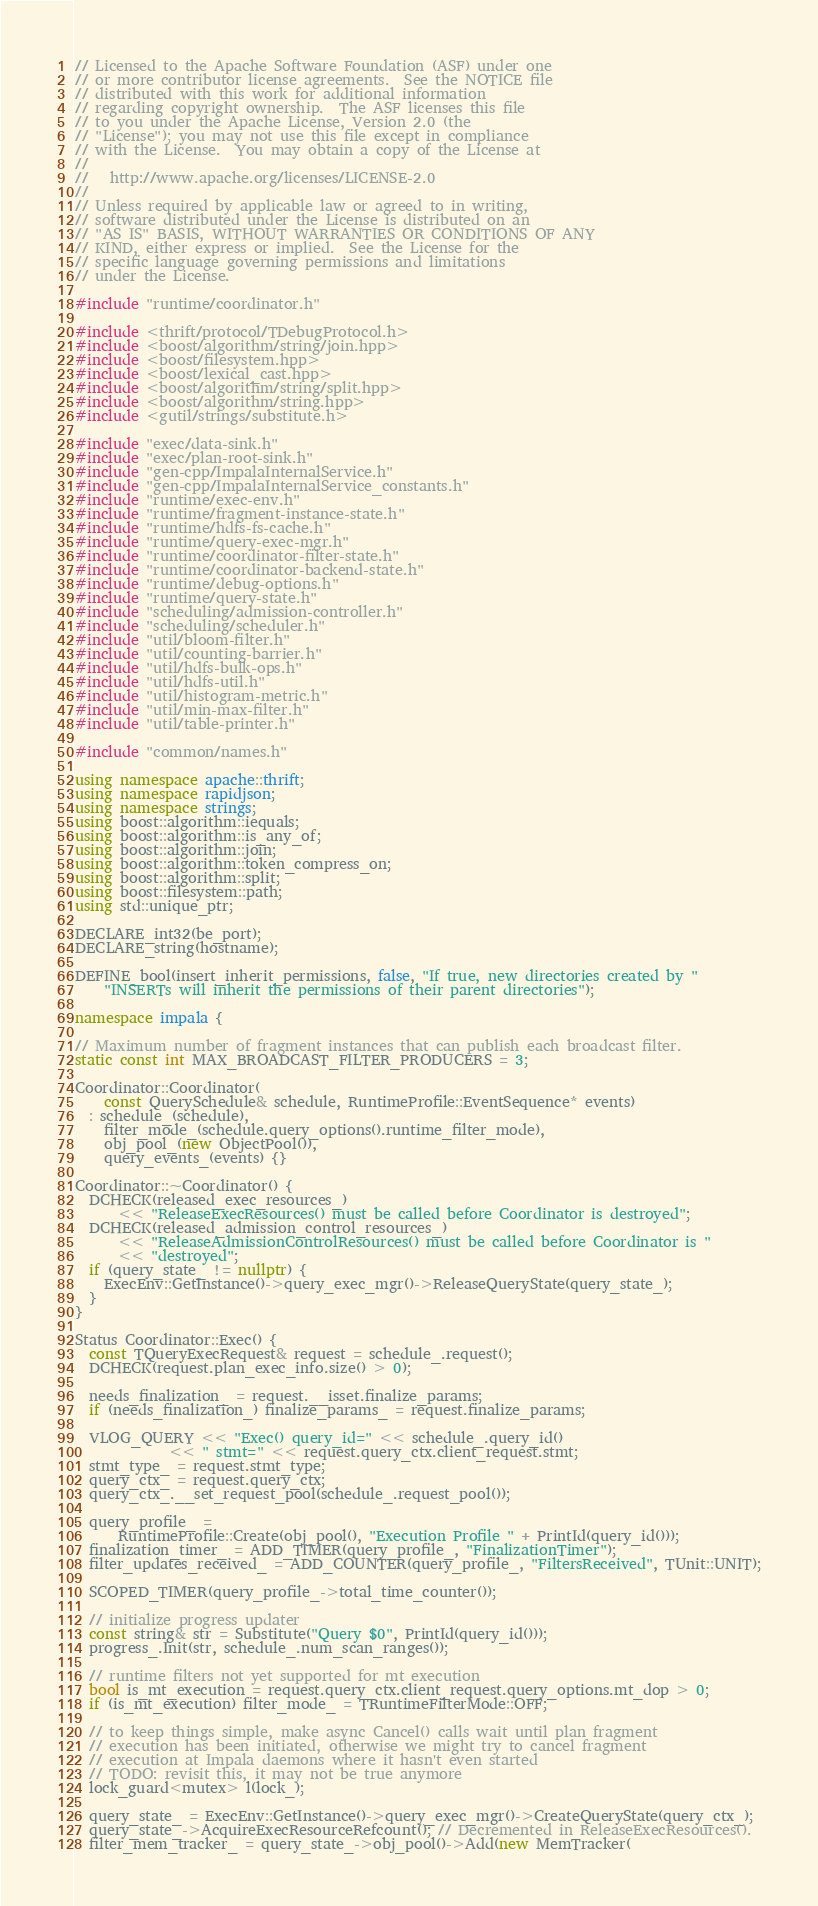<code> <loc_0><loc_0><loc_500><loc_500><_C++_>// Licensed to the Apache Software Foundation (ASF) under one
// or more contributor license agreements.  See the NOTICE file
// distributed with this work for additional information
// regarding copyright ownership.  The ASF licenses this file
// to you under the Apache License, Version 2.0 (the
// "License"); you may not use this file except in compliance
// with the License.  You may obtain a copy of the License at
//
//   http://www.apache.org/licenses/LICENSE-2.0
//
// Unless required by applicable law or agreed to in writing,
// software distributed under the License is distributed on an
// "AS IS" BASIS, WITHOUT WARRANTIES OR CONDITIONS OF ANY
// KIND, either express or implied.  See the License for the
// specific language governing permissions and limitations
// under the License.

#include "runtime/coordinator.h"

#include <thrift/protocol/TDebugProtocol.h>
#include <boost/algorithm/string/join.hpp>
#include <boost/filesystem.hpp>
#include <boost/lexical_cast.hpp>
#include <boost/algorithm/string/split.hpp>
#include <boost/algorithm/string.hpp>
#include <gutil/strings/substitute.h>

#include "exec/data-sink.h"
#include "exec/plan-root-sink.h"
#include "gen-cpp/ImpalaInternalService.h"
#include "gen-cpp/ImpalaInternalService_constants.h"
#include "runtime/exec-env.h"
#include "runtime/fragment-instance-state.h"
#include "runtime/hdfs-fs-cache.h"
#include "runtime/query-exec-mgr.h"
#include "runtime/coordinator-filter-state.h"
#include "runtime/coordinator-backend-state.h"
#include "runtime/debug-options.h"
#include "runtime/query-state.h"
#include "scheduling/admission-controller.h"
#include "scheduling/scheduler.h"
#include "util/bloom-filter.h"
#include "util/counting-barrier.h"
#include "util/hdfs-bulk-ops.h"
#include "util/hdfs-util.h"
#include "util/histogram-metric.h"
#include "util/min-max-filter.h"
#include "util/table-printer.h"

#include "common/names.h"

using namespace apache::thrift;
using namespace rapidjson;
using namespace strings;
using boost::algorithm::iequals;
using boost::algorithm::is_any_of;
using boost::algorithm::join;
using boost::algorithm::token_compress_on;
using boost::algorithm::split;
using boost::filesystem::path;
using std::unique_ptr;

DECLARE_int32(be_port);
DECLARE_string(hostname);

DEFINE_bool(insert_inherit_permissions, false, "If true, new directories created by "
    "INSERTs will inherit the permissions of their parent directories");

namespace impala {

// Maximum number of fragment instances that can publish each broadcast filter.
static const int MAX_BROADCAST_FILTER_PRODUCERS = 3;

Coordinator::Coordinator(
    const QuerySchedule& schedule, RuntimeProfile::EventSequence* events)
  : schedule_(schedule),
    filter_mode_(schedule.query_options().runtime_filter_mode),
    obj_pool_(new ObjectPool()),
    query_events_(events) {}

Coordinator::~Coordinator() {
  DCHECK(released_exec_resources_)
      << "ReleaseExecResources() must be called before Coordinator is destroyed";
  DCHECK(released_admission_control_resources_)
      << "ReleaseAdmissionControlResources() must be called before Coordinator is "
      << "destroyed";
  if (query_state_ != nullptr) {
    ExecEnv::GetInstance()->query_exec_mgr()->ReleaseQueryState(query_state_);
  }
}

Status Coordinator::Exec() {
  const TQueryExecRequest& request = schedule_.request();
  DCHECK(request.plan_exec_info.size() > 0);

  needs_finalization_ = request.__isset.finalize_params;
  if (needs_finalization_) finalize_params_ = request.finalize_params;

  VLOG_QUERY << "Exec() query_id=" << schedule_.query_id()
             << " stmt=" << request.query_ctx.client_request.stmt;
  stmt_type_ = request.stmt_type;
  query_ctx_ = request.query_ctx;
  query_ctx_.__set_request_pool(schedule_.request_pool());

  query_profile_ =
      RuntimeProfile::Create(obj_pool(), "Execution Profile " + PrintId(query_id()));
  finalization_timer_ = ADD_TIMER(query_profile_, "FinalizationTimer");
  filter_updates_received_ = ADD_COUNTER(query_profile_, "FiltersReceived", TUnit::UNIT);

  SCOPED_TIMER(query_profile_->total_time_counter());

  // initialize progress updater
  const string& str = Substitute("Query $0", PrintId(query_id()));
  progress_.Init(str, schedule_.num_scan_ranges());

  // runtime filters not yet supported for mt execution
  bool is_mt_execution = request.query_ctx.client_request.query_options.mt_dop > 0;
  if (is_mt_execution) filter_mode_ = TRuntimeFilterMode::OFF;

  // to keep things simple, make async Cancel() calls wait until plan fragment
  // execution has been initiated, otherwise we might try to cancel fragment
  // execution at Impala daemons where it hasn't even started
  // TODO: revisit this, it may not be true anymore
  lock_guard<mutex> l(lock_);

  query_state_ = ExecEnv::GetInstance()->query_exec_mgr()->CreateQueryState(query_ctx_);
  query_state_->AcquireExecResourceRefcount(); // Decremented in ReleaseExecResources().
  filter_mem_tracker_ = query_state_->obj_pool()->Add(new MemTracker(</code> 